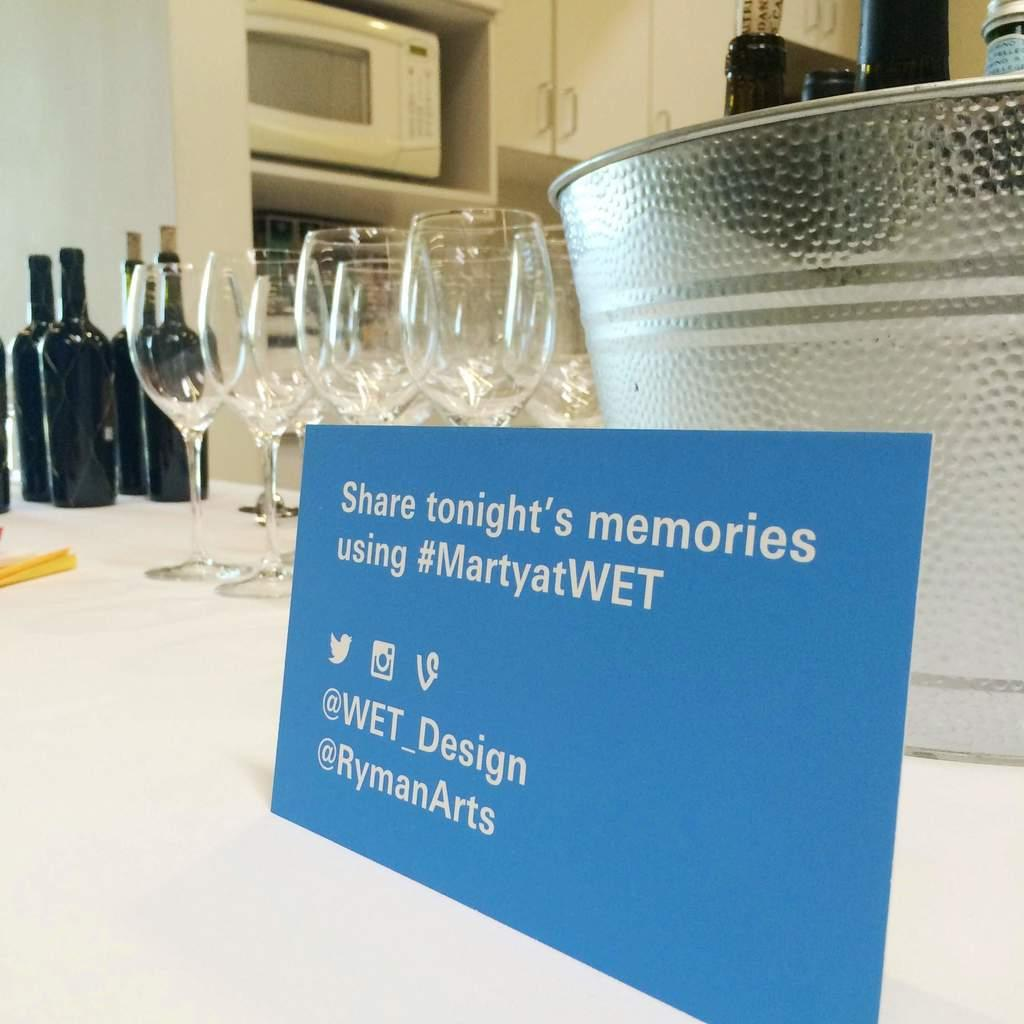<image>
Offer a succinct explanation of the picture presented. a bar with glasses and bottles and note that says Share tonight's memories 